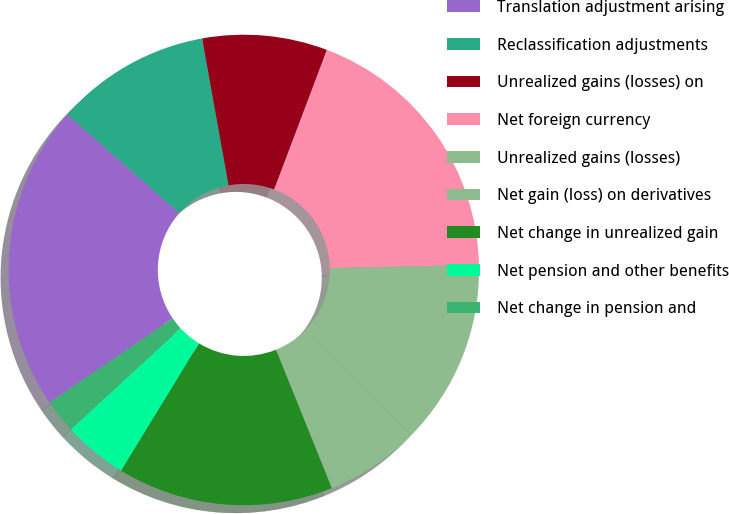Convert chart to OTSL. <chart><loc_0><loc_0><loc_500><loc_500><pie_chart><fcel>Translation adjustment arising<fcel>Reclassification adjustments<fcel>Unrealized gains (losses) on<fcel>Net foreign currency<fcel>Unrealized gains (losses)<fcel>Net gain (loss) on derivatives<fcel>Net change in unrealized gain<fcel>Net pension and other benefits<fcel>Net change in pension and<nl><fcel>21.03%<fcel>10.67%<fcel>8.58%<fcel>18.91%<fcel>12.75%<fcel>6.49%<fcel>14.84%<fcel>4.41%<fcel>2.32%<nl></chart> 